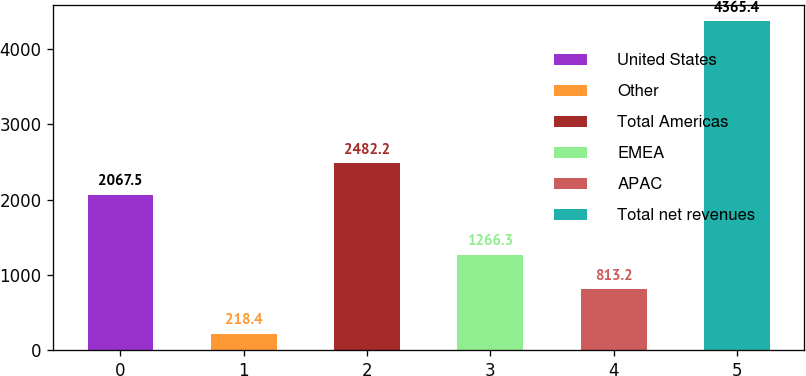<chart> <loc_0><loc_0><loc_500><loc_500><bar_chart><fcel>United States<fcel>Other<fcel>Total Americas<fcel>EMEA<fcel>APAC<fcel>Total net revenues<nl><fcel>2067.5<fcel>218.4<fcel>2482.2<fcel>1266.3<fcel>813.2<fcel>4365.4<nl></chart> 